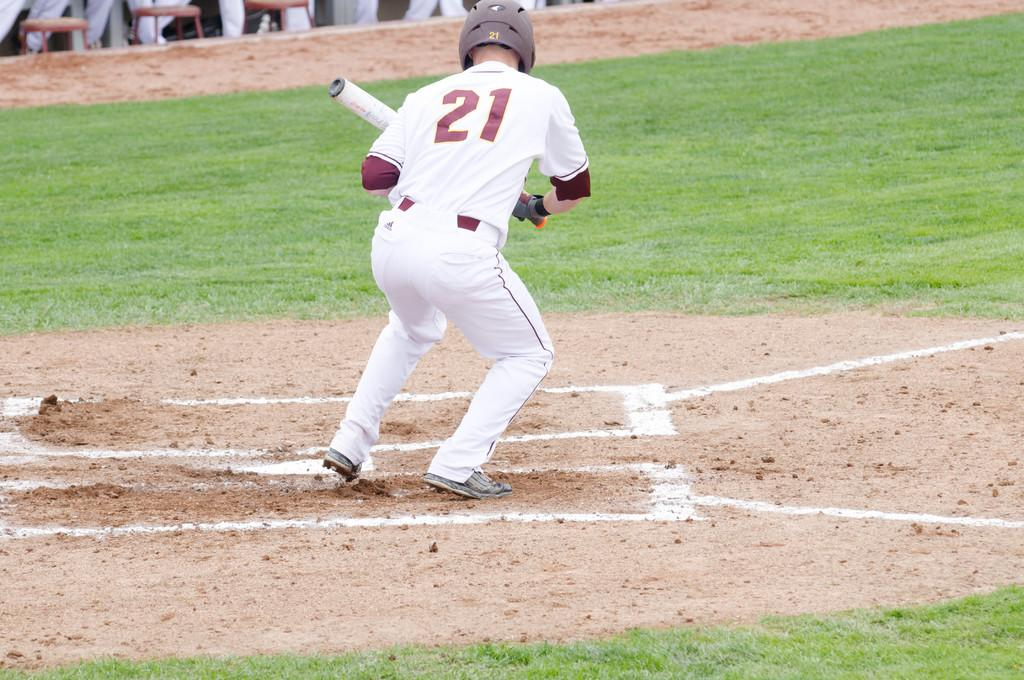<image>
Summarize the visual content of the image. A batter numbered 21 is ready to bunt and head for the first base. 